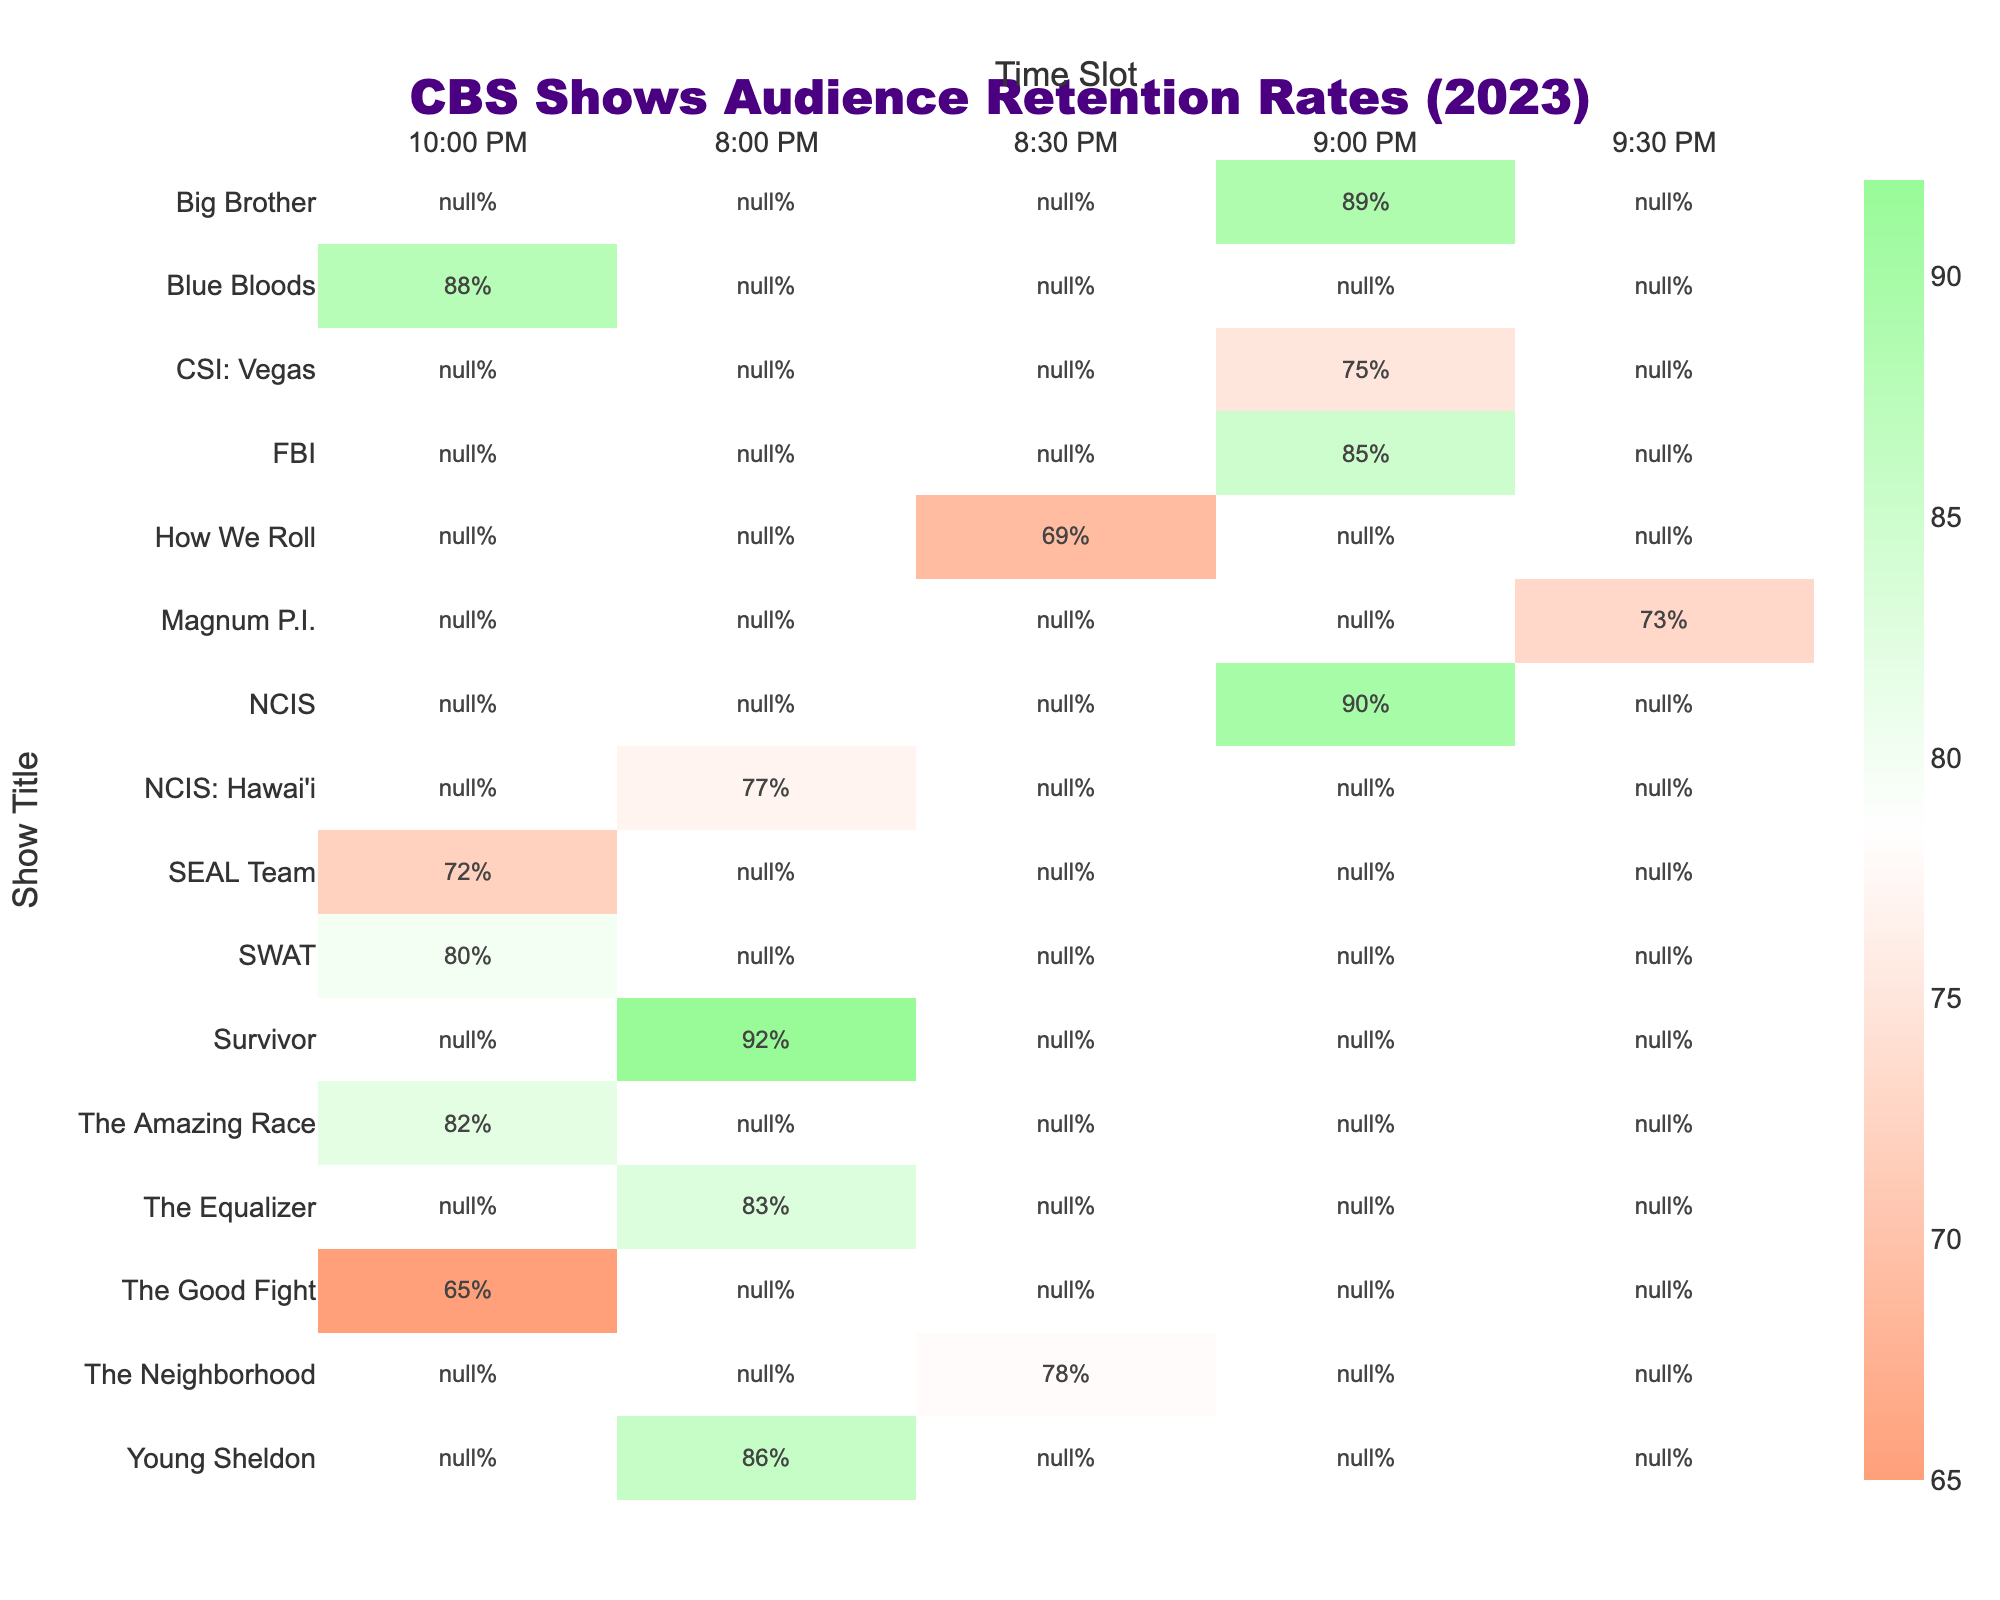What is the audience retention rate for "Young Sheldon"? The table shows that the audience retention rate for "Young Sheldon" is 86%.
Answer: 86% Which show had the lowest audience retention rate in the 10:00 PM time slot? Looking at the 10:00 PM time slot, "The Good Fight" has the lowest audience retention rate at 65%.
Answer: 65% What is the average audience retention rate for shows airing at 9:00 PM? The shows airing at 9:00 PM are "NCIS" (90%), "FBI" (85%), "CSI: Vegas" (75%), and "Big Brother" (89%). The average is (90 + 85 + 75 + 89) / 4 = 84.75.
Answer: 84.75 Which show has a higher audience retention rate, "The Neighborhood" or "NCIS: Hawai'i"? "The Neighborhood" has a retention rate of 78%, while "NCIS: Hawai'i" has a retention rate of 77%. Comparing the two, "The Neighborhood" has a higher rate.
Answer: "The Neighborhood" What is the difference between the retention rates of "Blue Bloods" and "SWAT"? "Blue Bloods" has a retention rate of 88%, while "SWAT" has 80%. The difference is 88 - 80 = 8%.
Answer: 8% Are there any shows in the 8:00 PM time slot that have an audience retention rate above 80%? The table shows "Young Sheldon" (86%) and "The Equalizer" (83%) in the 8:00 PM slot, both of which have retention rates above 80%.
Answer: Yes Which time slot has the highest average audience retention rate across all shows? The 8:00 PM shows are "Young Sheldon" (86%), "The Equalizer" (83%), "NCIS: Hawai'i" (77%), and "Survivor" (92%). The average is (86 + 83 + 77 + 92) / 4 = 84.5%. The 9:00 PM shows average (90 + 85 + 75 + 89) / 4 = 84.75%, and the 10:00 PM shows average (88 + 80 + 72 + 65) / 4 = 76.25%. Therefore, the highest average is from the 9:00 PM slot.
Answer: 9:00 PM If we combine the retention rates of "CSI: Vegas" and "Magnum P.I.", what is their total? "CSI: Vegas" has a rate of 75%, and "Magnum P.I." has a rate of 73%. Their combined total is 75 + 73 = 148%.
Answer: 148% What percentage of shows listed have an audience retention rate below 70%? The shows "How We Roll" (69%) and "The Good Fight" (65%) have retention rates below 70%. There are 2 such shows out of a total of 12 shows listed, giving 2/12 = 16.67%.
Answer: Approximately 17% Is "The Amazing Race" performing better than "SEAL Team" in terms of audience retention? "The Amazing Race" has a retention rate of 82%, while "SEAL Team" has 72%. Since 82 > 72, "The Amazing Race" is performing better.
Answer: Yes 